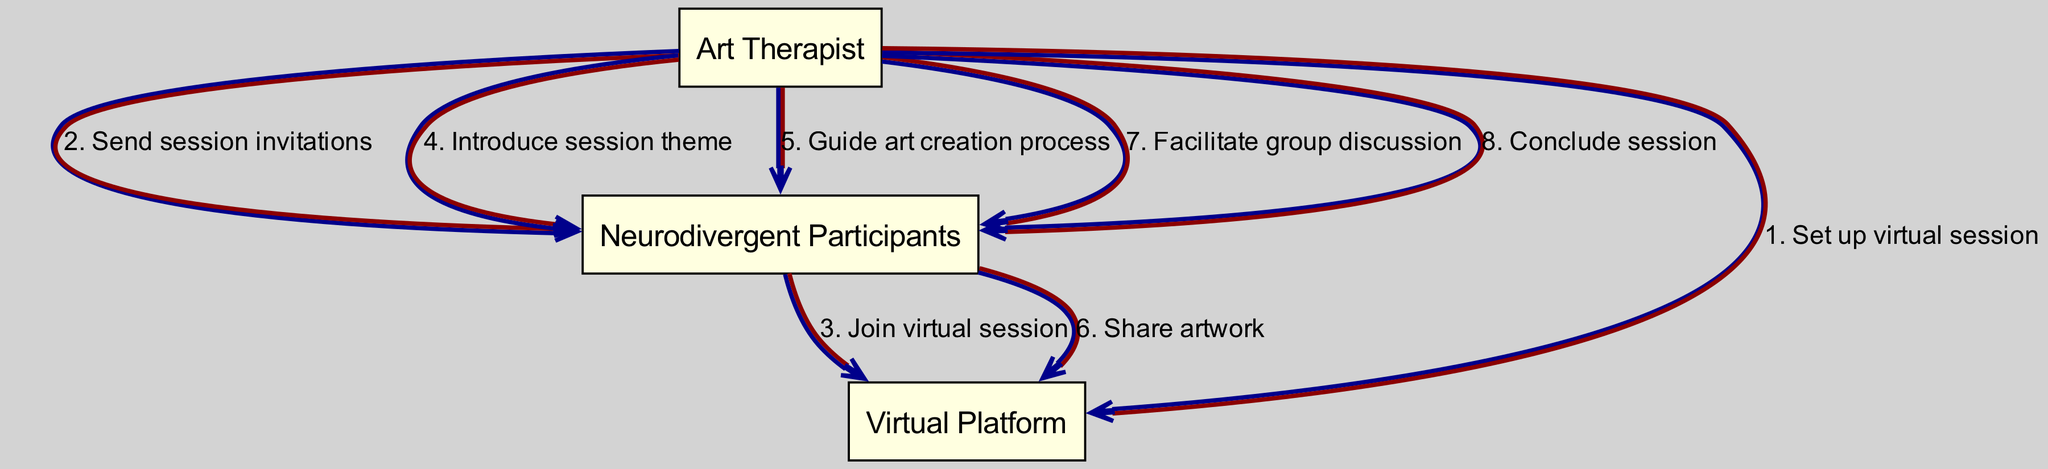What are the participants in the session? The diagram lists the participants: Art Therapist, Neurodivergent Participants, and Virtual Platform. These are the three entities involved in the sequence of actions.
Answer: Art Therapist, Neurodivergent Participants, Virtual Platform How many actions are shown in the sequence? By counting the entries in the sequence list, there are a total of 8 distinct actions that occur between the participants.
Answer: 8 Who sends the session invitations? The diagram indicates that the Art Therapist is responsible for sending out the session invitations to the Neurodivergent Participants as part of the organized sequence of actions.
Answer: Art Therapist What is the action taken by Neurodivergent Participants after receiving the invitations? The Neurodivergent Participants join the virtual session after the invitations are sent, which follows the sequence as indicated in the diagram.
Answer: Join virtual session What is the first action taken in the sequence? The first action listed in the sequence is initiated by the Art Therapist, who sets up the virtual session. This is the starting point of the entire process.
Answer: Set up virtual session How does the Art Therapist involve Neurodivergent Participants after the session theme is introduced? After introducing the session theme, the Art Therapist guides the Neurodivergent Participants through the art creation process, which is the next action in the flow. This shows ongoing engagement with participants.
Answer: Guide art creation process What happens after Neurodivergent Participants share their artwork? After sharing their artwork, the next action is that the Art Therapist facilitates a group discussion, allowing for reflection and interaction among the participants.
Answer: Facilitate group discussion What action concludes the session? The session concludes with an action from the Art Therapist, as indicated in the last step of the sequence diagram, where they officially conclude the session with the participants.
Answer: Conclude session 